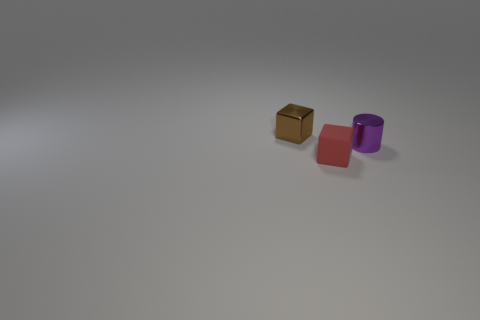There is a small cube behind the object in front of the purple object; what number of cylinders are behind it?
Offer a terse response. 0. What number of purple shiny objects are the same shape as the tiny brown object?
Make the answer very short. 0. Is the color of the thing on the right side of the red matte object the same as the matte object?
Offer a very short reply. No. There is a tiny metallic object on the left side of the metal object that is in front of the object that is behind the tiny metal cylinder; what is its shape?
Provide a short and direct response. Cube. Is the size of the brown cube the same as the object that is in front of the purple shiny thing?
Your answer should be very brief. Yes. Are there any objects that have the same size as the metal cylinder?
Offer a terse response. Yes. How many other objects are there of the same material as the purple thing?
Your answer should be very brief. 1. What is the color of the thing that is both on the right side of the small brown metal block and behind the red thing?
Your answer should be very brief. Purple. Do the block that is in front of the brown cube and the cube that is behind the small cylinder have the same material?
Your response must be concise. No. There is a cube that is in front of the shiny cube; is it the same size as the purple thing?
Provide a short and direct response. Yes. 